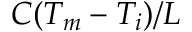<formula> <loc_0><loc_0><loc_500><loc_500>C ( T _ { m } - T _ { i } ) / L</formula> 